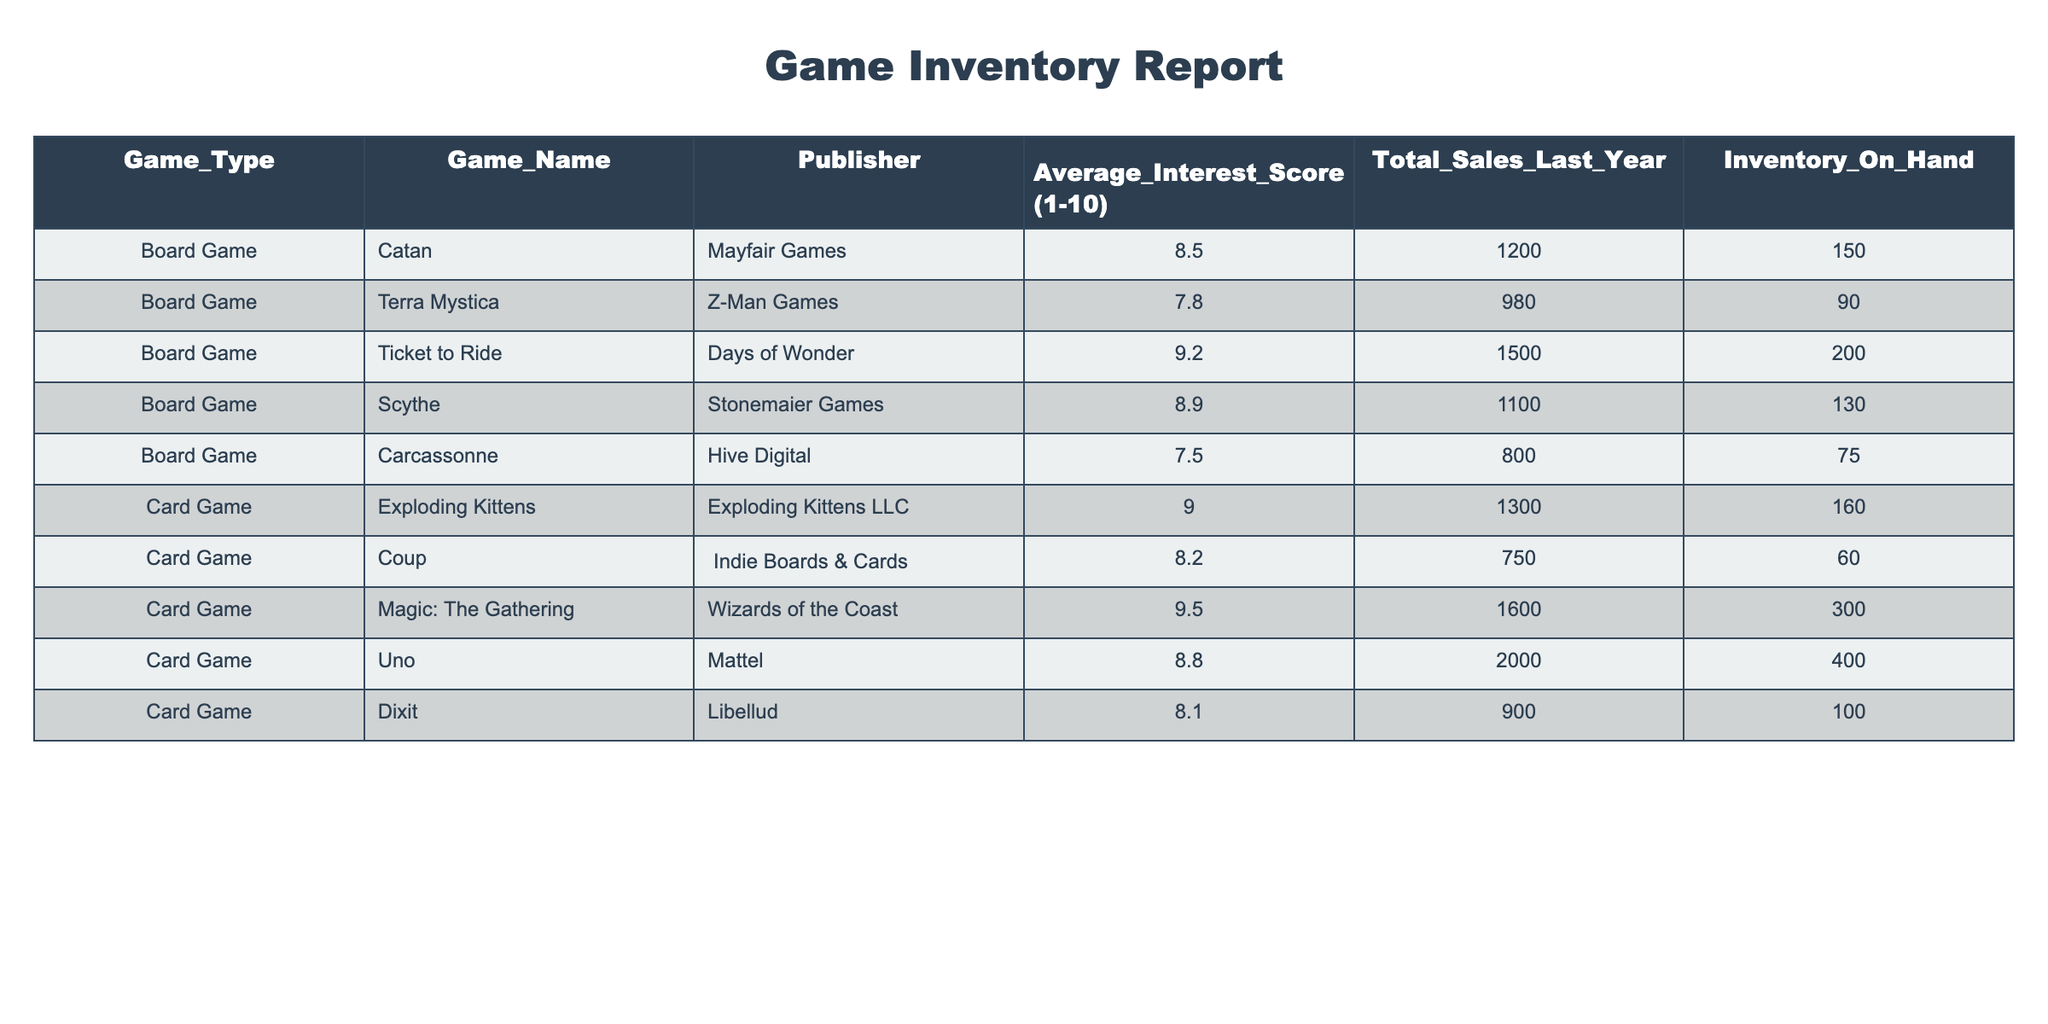What is the Average Interest Score for Board Games? The Average Interest Scores for Board Games listed are 8.5 for Catan, 7.8 for Terra Mystica, 9.2 for Ticket to Ride, 8.9 for Scythe, and 7.5 for Carcassonne. To find the average, we sum these scores: 8.5 + 7.8 + 9.2 + 8.9 + 7.5 = 42.9. We then divide this by the number of Board Games, which is 5: 42.9 / 5 = 8.58.
Answer: 8.58 Which Card Game has the highest Average Interest Score? Looking at the Card Games listed: Exploding Kittens has an interest score of 9.0, Coup has 8.2, Magic: The Gathering has 9.5, Uno has 8.8, and Dixit has 8.1. The maximum score is 9.5 for Magic: The Gathering.
Answer: Magic: The Gathering Is the Total Sales of Card Games higher than Board Games? The Total Sales for Card Games are 1300 for Exploding Kittens, 750 for Coup, 1600 for Magic: The Gathering, 2000 for Uno, and 900 for Dixit. The total of these sales is 1300 + 750 + 1600 + 2000 + 900 = 7550. For Board Games, the sales are 1200 for Catan, 980 for Terra Mystica, 1500 for Ticket to Ride, 1100 for Scythe, and 800 for Carcassonne, giving a total of 1200 + 980 + 1500 + 1100 + 800 = 4580. Since 7550 is greater than 4580, the statement is true.
Answer: Yes What is the total inventory for Card Games? The inventory quantities for Card Games are 160 for Exploding Kittens, 60 for Coup, 300 for Magic: The Gathering, 400 for Uno, and 100 for Dixit. To find the total inventory, we sum these quantities: 160 + 60 + 300 + 400 + 100 = 1020.
Answer: 1020 Which game had the lowest Average Interest Score? Reviewing both Board and Card Games, the scores for Board Games are 8.5, 7.8, 9.2, 8.9, and 7.5, while the scores for Card Games are 9.0, 8.2, 9.5, 8.8, and 8.1. The lowest score from Board Games is 7.5 (Carcassonne), and from Card Games, it's 8.1 (Dixit). The overall lowest score is 7.5.
Answer: Carcassonne 